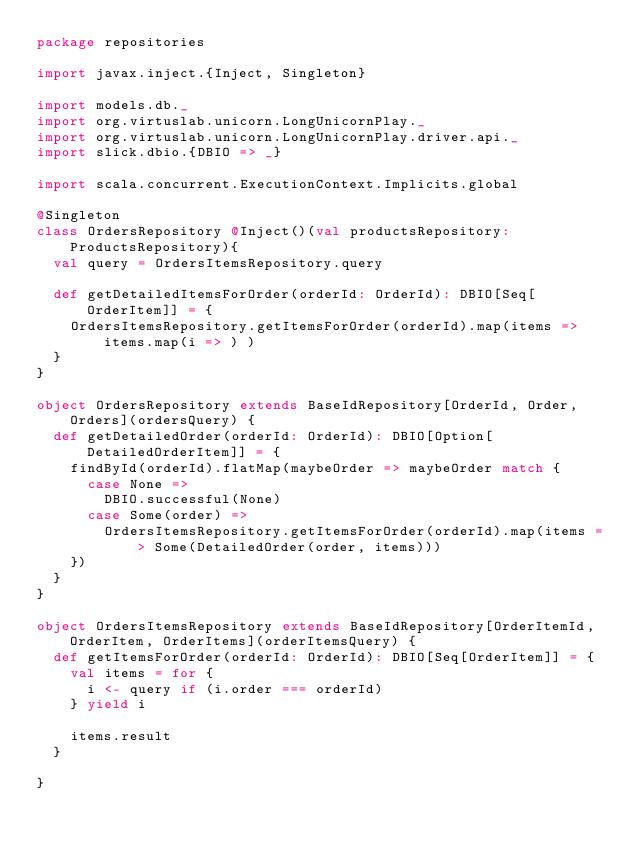<code> <loc_0><loc_0><loc_500><loc_500><_Scala_>package repositories

import javax.inject.{Inject, Singleton}

import models.db._
import org.virtuslab.unicorn.LongUnicornPlay._
import org.virtuslab.unicorn.LongUnicornPlay.driver.api._
import slick.dbio.{DBIO => _}

import scala.concurrent.ExecutionContext.Implicits.global

@Singleton
class OrdersRepository @Inject()(val productsRepository: ProductsRepository){
  val query = OrdersItemsRepository.query

  def getDetailedItemsForOrder(orderId: OrderId): DBIO[Seq[OrderItem]] = {
    OrdersItemsRepository.getItemsForOrder(orderId).map(items => items.map(i => ) )
  }
}

object OrdersRepository extends BaseIdRepository[OrderId, Order, Orders](ordersQuery) {
  def getDetailedOrder(orderId: OrderId): DBIO[Option[DetailedOrderItem]] = {
    findById(orderId).flatMap(maybeOrder => maybeOrder match {
      case None =>
        DBIO.successful(None)
      case Some(order) =>
        OrdersItemsRepository.getItemsForOrder(orderId).map(items => Some(DetailedOrder(order, items)))
    })
  }
}

object OrdersItemsRepository extends BaseIdRepository[OrderItemId, OrderItem, OrderItems](orderItemsQuery) {
  def getItemsForOrder(orderId: OrderId): DBIO[Seq[OrderItem]] = {
    val items = for {
      i <- query if (i.order === orderId)
    } yield i

    items.result
  }

}</code> 